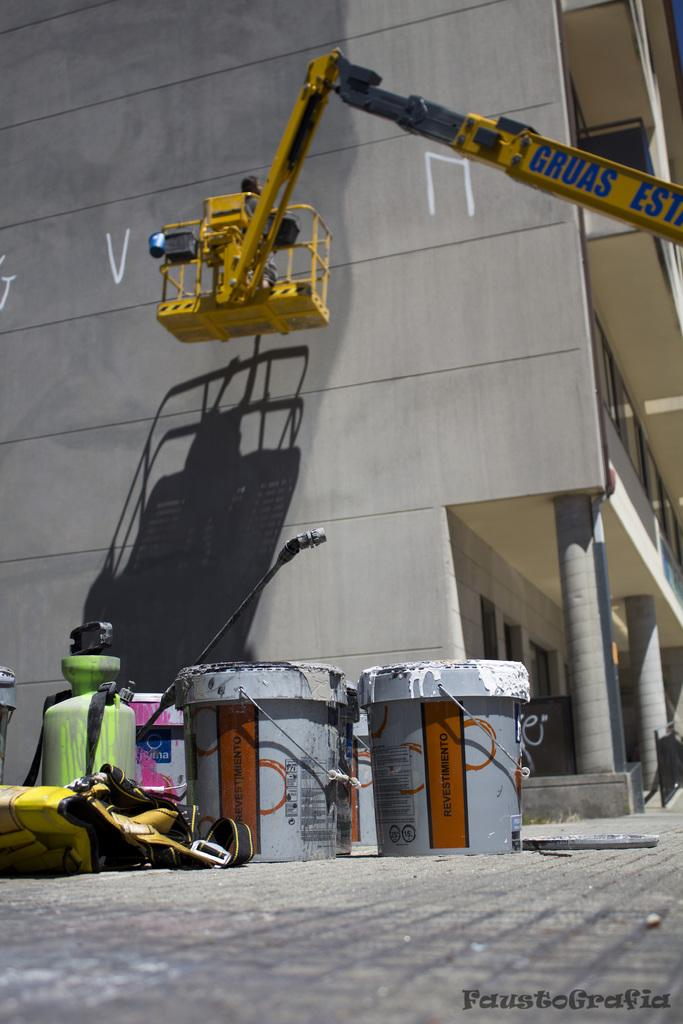What objects are on the ground in the image? There are paint buckets on the ground in the image. What type of structure can be seen in the image? There is a building in the image. What machinery is present in the image? There is a crane in the image. What type of attraction can be seen in the image? There is no attraction present in the image; it features paint buckets, a building, and a crane. What type of silk is draped over the crane in the image? There is no silk present in the image; it only features paint buckets, a building, and a crane. 